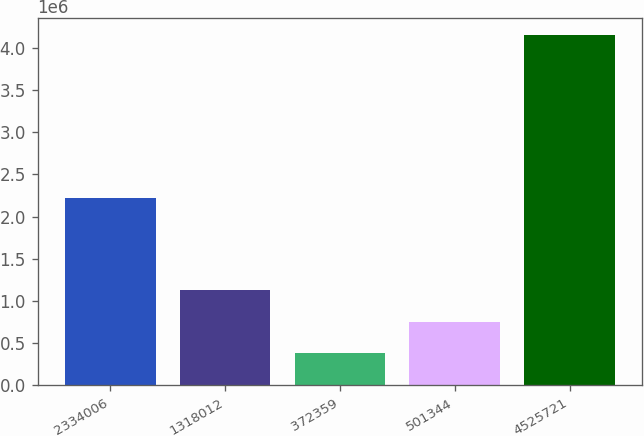<chart> <loc_0><loc_0><loc_500><loc_500><bar_chart><fcel>2334006<fcel>1318012<fcel>372359<fcel>501344<fcel>4525721<nl><fcel>2.21403e+06<fcel>1.13148e+06<fcel>377847<fcel>754664<fcel>4.14601e+06<nl></chart> 